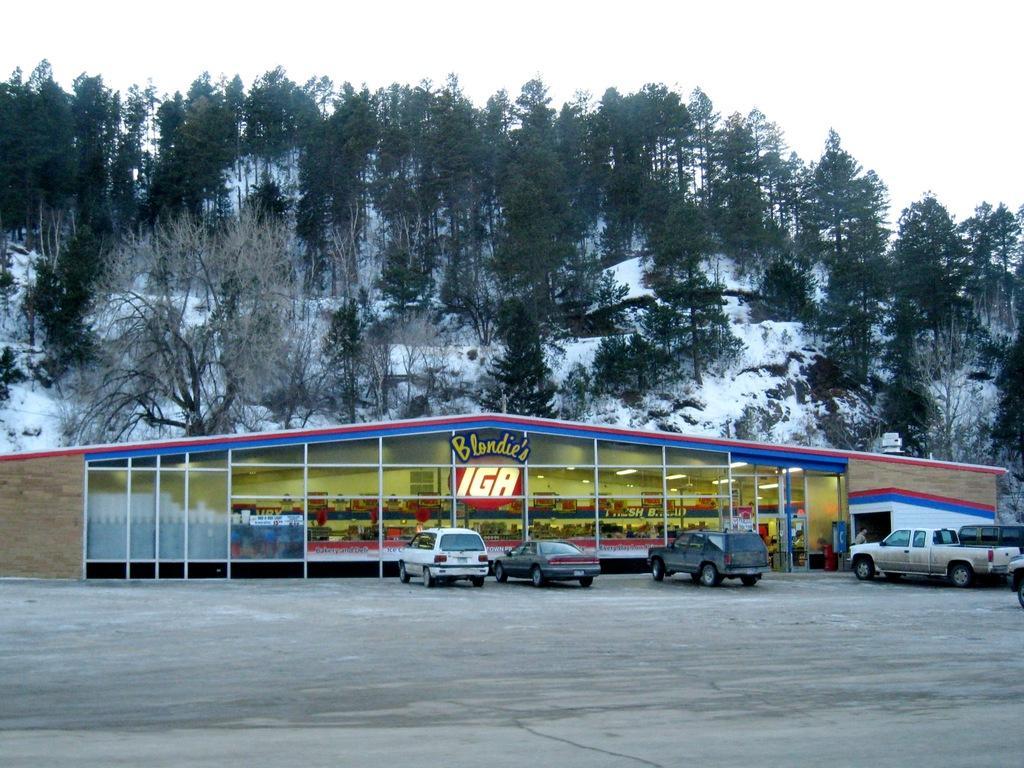Could you give a brief overview of what you see in this image? In this image we can see a building with text, and there are few objects and lights inside the building and there are few vehicles parked on the road in front of the building and there are few trees, snow and the sky in the background. 